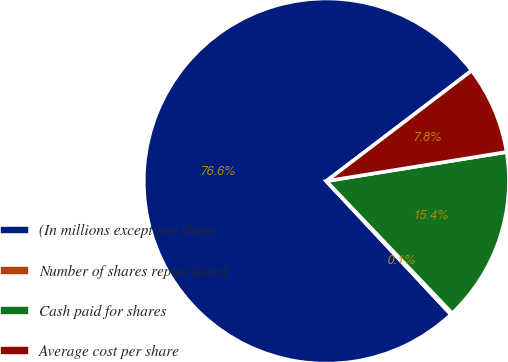<chart> <loc_0><loc_0><loc_500><loc_500><pie_chart><fcel>(In millions except per share<fcel>Number of shares repurchased<fcel>Cash paid for shares<fcel>Average cost per share<nl><fcel>76.61%<fcel>0.15%<fcel>15.44%<fcel>7.8%<nl></chart> 